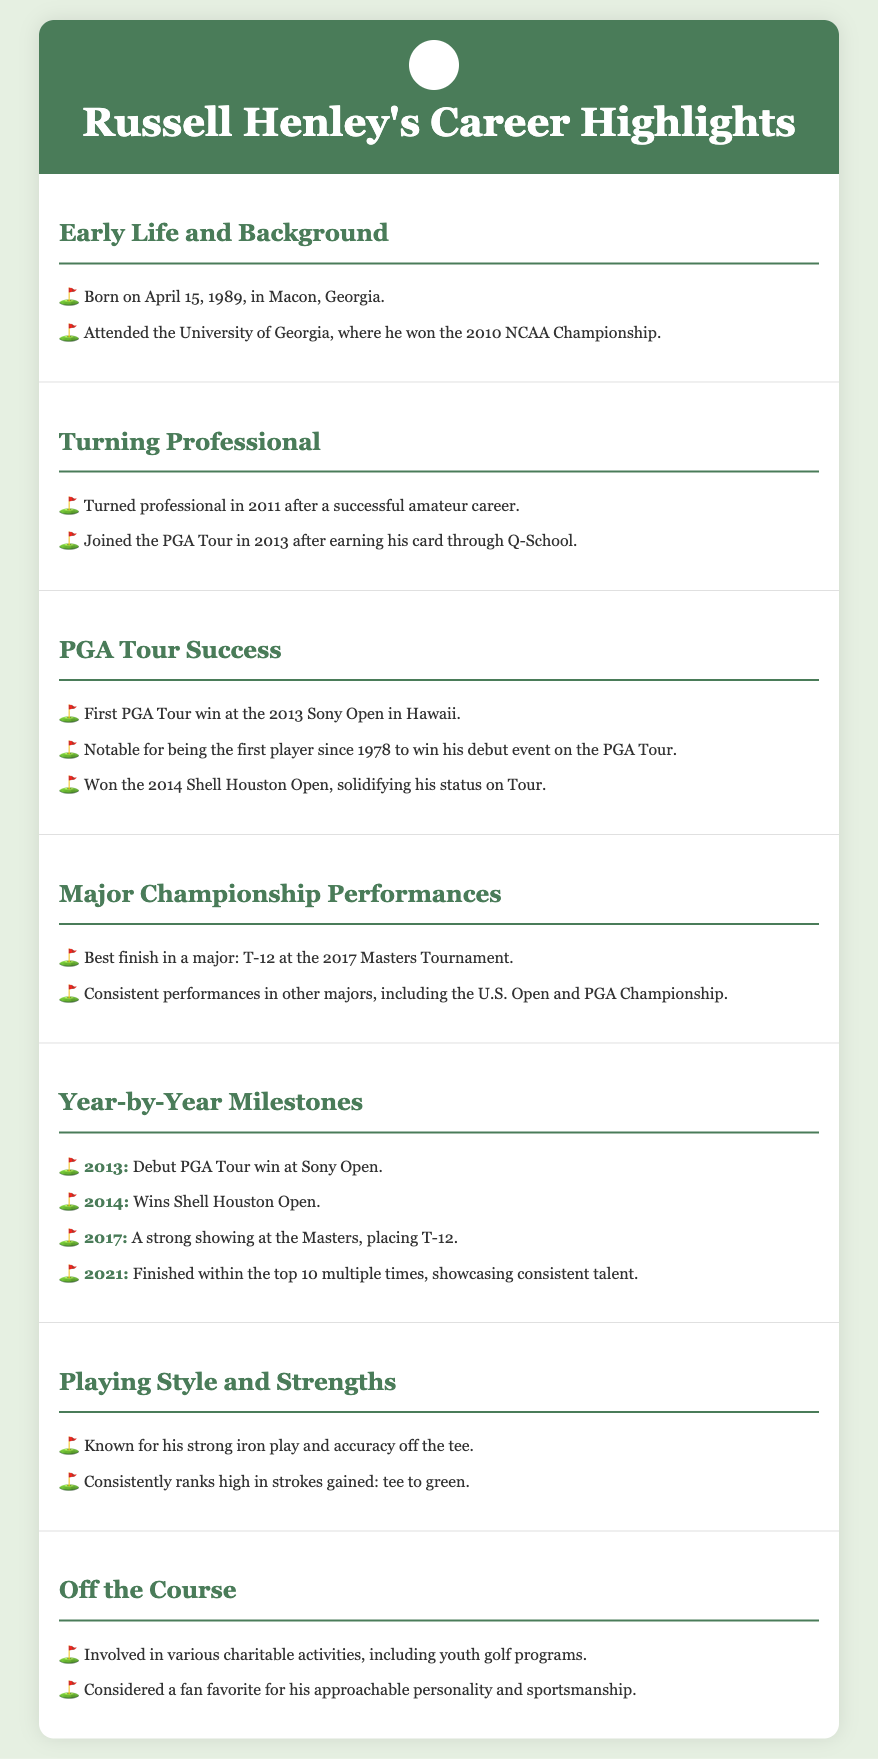What year was Russell Henley born? Russell Henley was born on April 15, 1989, as mentioned in the Early Life and Background section.
Answer: 1989 What tournament did Russell Henley win in 2013? The document states that Henley won the Sony Open in Hawaii in 2013, marking his first PGA Tour victory.
Answer: Sony Open Which championship did he win in 2014? The document indicates that Henley won the Shell Houston Open in 2014, solidifying his status on Tour.
Answer: Shell Houston Open What was Henley's best finish in a major? The best finish in a major tournament for Henley, as stated in the Major Championship Performances section, was T-12 at the 2017 Masters Tournament.
Answer: T-12 How many times did Henley finish in the top 10 in 2021? The Year-by-Year Milestones section mentions that he finished within the top 10 multiple times in 2021, showcasing consistent talent.
Answer: Multiple times What aspect of his game is Russell Henley known for? The Playing Style and Strengths section describes Henley as being known for his strong iron play and accuracy off the tee.
Answer: Strong iron play In what way is Russell Henley involved off the golf course? According to the Off the Course section, Henley is involved in various charitable activities, including youth golf programs.
Answer: Charitable activities What university did Russell Henley attend? The document mentions that he attended the University of Georgia, where he won the 2010 NCAA Championship.
Answer: University of Georgia 